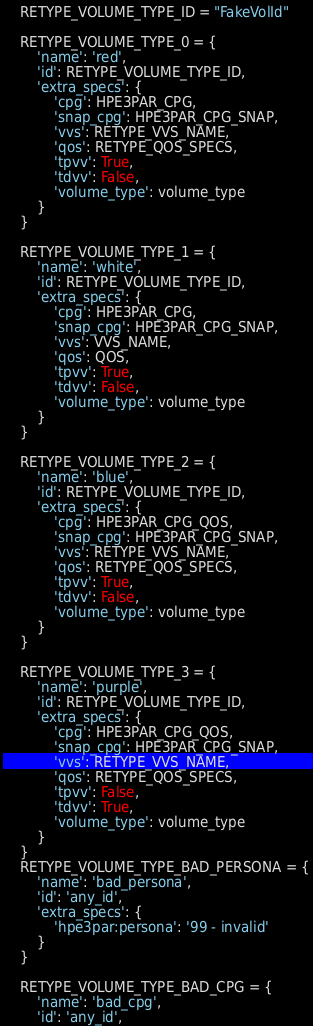<code> <loc_0><loc_0><loc_500><loc_500><_Python_>
    RETYPE_VOLUME_TYPE_ID = "FakeVolId"

    RETYPE_VOLUME_TYPE_0 = {
        'name': 'red',
        'id': RETYPE_VOLUME_TYPE_ID,
        'extra_specs': {
            'cpg': HPE3PAR_CPG,
            'snap_cpg': HPE3PAR_CPG_SNAP,
            'vvs': RETYPE_VVS_NAME,
            'qos': RETYPE_QOS_SPECS,
            'tpvv': True,
            'tdvv': False,
            'volume_type': volume_type
        }
    }

    RETYPE_VOLUME_TYPE_1 = {
        'name': 'white',
        'id': RETYPE_VOLUME_TYPE_ID,
        'extra_specs': {
            'cpg': HPE3PAR_CPG,
            'snap_cpg': HPE3PAR_CPG_SNAP,
            'vvs': VVS_NAME,
            'qos': QOS,
            'tpvv': True,
            'tdvv': False,
            'volume_type': volume_type
        }
    }

    RETYPE_VOLUME_TYPE_2 = {
        'name': 'blue',
        'id': RETYPE_VOLUME_TYPE_ID,
        'extra_specs': {
            'cpg': HPE3PAR_CPG_QOS,
            'snap_cpg': HPE3PAR_CPG_SNAP,
            'vvs': RETYPE_VVS_NAME,
            'qos': RETYPE_QOS_SPECS,
            'tpvv': True,
            'tdvv': False,
            'volume_type': volume_type
        }
    }

    RETYPE_VOLUME_TYPE_3 = {
        'name': 'purple',
        'id': RETYPE_VOLUME_TYPE_ID,
        'extra_specs': {
            'cpg': HPE3PAR_CPG_QOS,
            'snap_cpg': HPE3PAR_CPG_SNAP,
            'vvs': RETYPE_VVS_NAME,
            'qos': RETYPE_QOS_SPECS,
            'tpvv': False,
            'tdvv': True,
            'volume_type': volume_type
        }
    }
    RETYPE_VOLUME_TYPE_BAD_PERSONA = {
        'name': 'bad_persona',
        'id': 'any_id',
        'extra_specs': {
            'hpe3par:persona': '99 - invalid'
        }
    }

    RETYPE_VOLUME_TYPE_BAD_CPG = {
        'name': 'bad_cpg',
        'id': 'any_id',</code> 